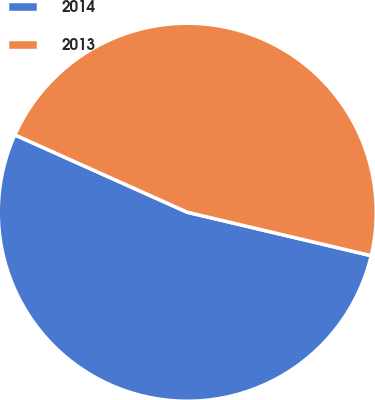<chart> <loc_0><loc_0><loc_500><loc_500><pie_chart><fcel>2014<fcel>2013<nl><fcel>53.02%<fcel>46.98%<nl></chart> 